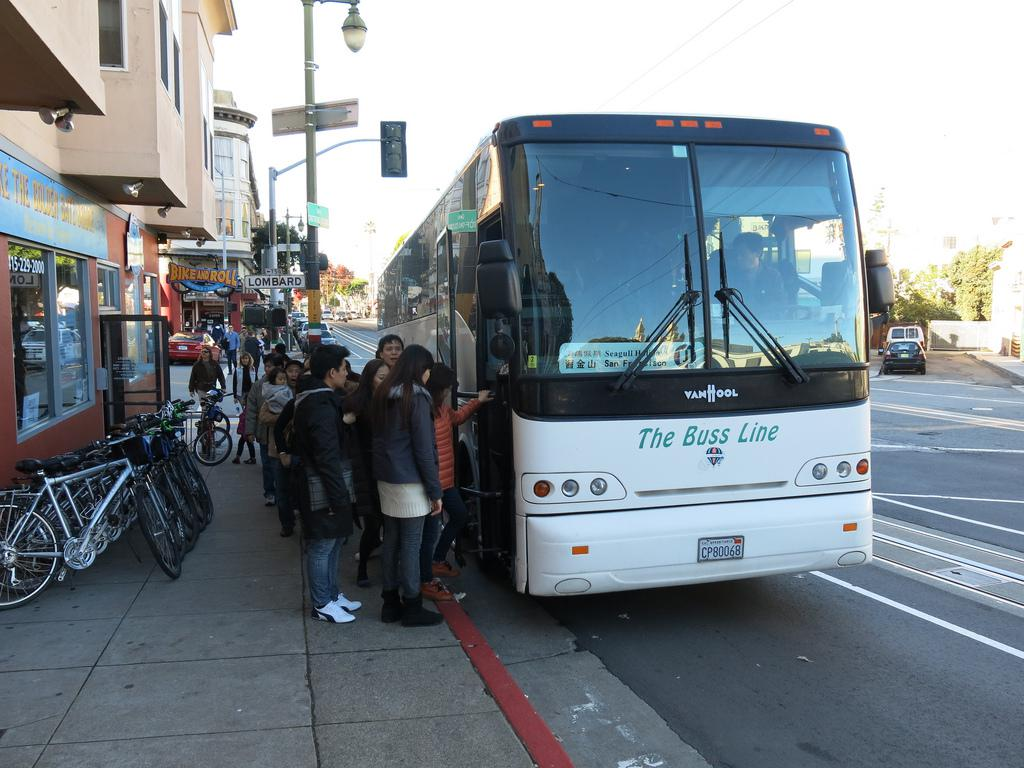Question: what color is the curb?
Choices:
A. Gray.
B. Black.
C. White.
D. The curb is red.
Answer with the letter. Answer: D Question: where are the vehicles parked?
Choices:
A. In the parking lot.
B. On the grass.
C. Next to the curb.
D. At the back.
Answer with the letter. Answer: D Question: what type of large, multi-passenger vehicle is pictured?
Choices:
A. A van.
B. A hatchback.
C. An SUV.
D. A bus.
Answer with the letter. Answer: D Question: when is the bus boarding?
Choices:
A. In five minutes.
B. Now.
C. In fifteen minutes.
D. In one hour.
Answer with the letter. Answer: B Question: what type of two wheeled transportation for individuals is pictured?
Choices:
A. Motorcycles.
B. Bicycles.
C. Scooters.
D. The Segway PT.
Answer with the letter. Answer: B Question: what color is the curb painted?
Choices:
A. Black.
B. Yellow.
C. White.
D. Red.
Answer with the letter. Answer: D Question: how many windshield wipers are seen?
Choices:
A. Four.
B. None.
C. Two.
D. One.
Answer with the letter. Answer: C Question: what name can be seen on the street sign behind the line of passengers waiting?
Choices:
A. Peachtree.
B. Lombard.
C. Centennial.
D. Hunters.
Answer with the letter. Answer: B Question: what is in the background?
Choices:
A. A streetlight.
B. The beach.
C. A park.
D. The sky.
Answer with the letter. Answer: A Question: what color is the sky?
Choices:
A. Blue.
B. It is white.
C. Black.
D. Light gray.
Answer with the letter. Answer: B Question: what words does the bus show?
Choices:
A. School Bus.
B. The destination of the bus.
C. The bus line.
D. The name of the team.
Answer with the letter. Answer: C Question: how is the weather?
Choices:
A. It looks like rain.
B. It is very windy.
C. The weather is pleasant today.
D. The sun is shining.
Answer with the letter. Answer: D Question: what is the man wearing?
Choices:
A. He wears white shoes.
B. He is wearing a silly hat.
C. He is wearing sunglasses.
D. He is wearing his favorite shirt.
Answer with the letter. Answer: A Question: how does the curb look?
Choices:
A. The curb is painted red.
B. The curb is dilapidated.
C. House numbers are painted on the curb.
D. The curb is angled sharply.
Answer with the letter. Answer: A Question: what has a timeline writing?
Choices:
A. The sign.
B. The train.
C. The marquee.
D. The bus.
Answer with the letter. Answer: D Question: what color is the street sign?
Choices:
A. Red.
B. White.
C. Green.
D. Yellow.
Answer with the letter. Answer: B Question: who is boarding the bus?
Choices:
A. Old ladies.
B. Boys and girls.
C. Dogs.
D. Men in suits.
Answer with the letter. Answer: B 